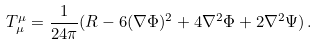Convert formula to latex. <formula><loc_0><loc_0><loc_500><loc_500>T _ { \mu } ^ { \mu } = \frac { 1 } { 2 4 \pi } ( R - 6 ( \nabla \Phi ) ^ { 2 } + 4 \nabla ^ { 2 } \Phi + 2 \nabla ^ { 2 } \Psi ) \, .</formula> 